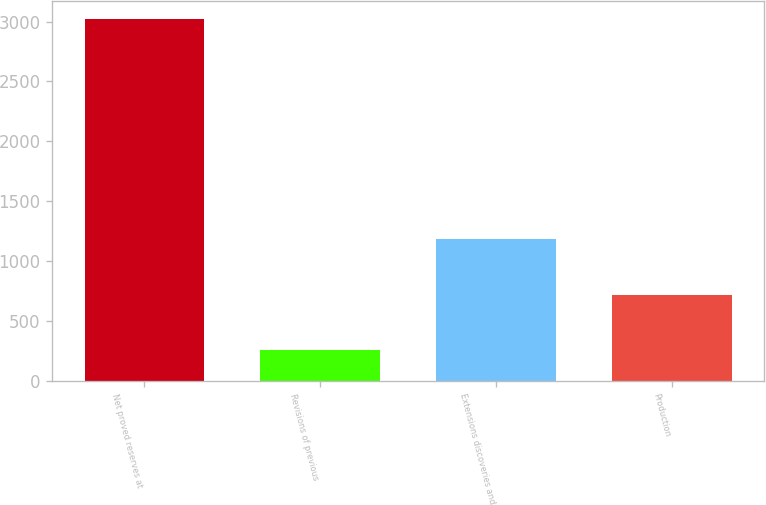Convert chart to OTSL. <chart><loc_0><loc_0><loc_500><loc_500><bar_chart><fcel>Net proved reserves at<fcel>Revisions of previous<fcel>Extensions discoveries and<fcel>Production<nl><fcel>3021.2<fcel>252.2<fcel>1182.86<fcel>717.53<nl></chart> 